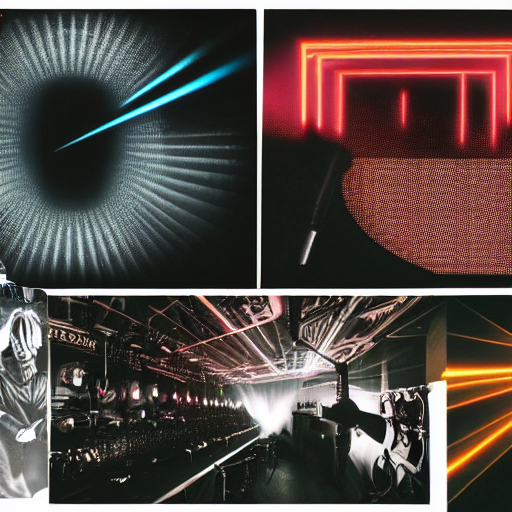Is the quality of the image good?
A. Average
B. No
C. Yes The quality of the image is quite impressive. It exhibits high resolution, sharp details, and vibrant contrast. The lighting effects in each quadrant are captured with clarity, suggesting a professional level of photography or digital rendering. Therefore, the answer is C, Yes, the image quality is good. 